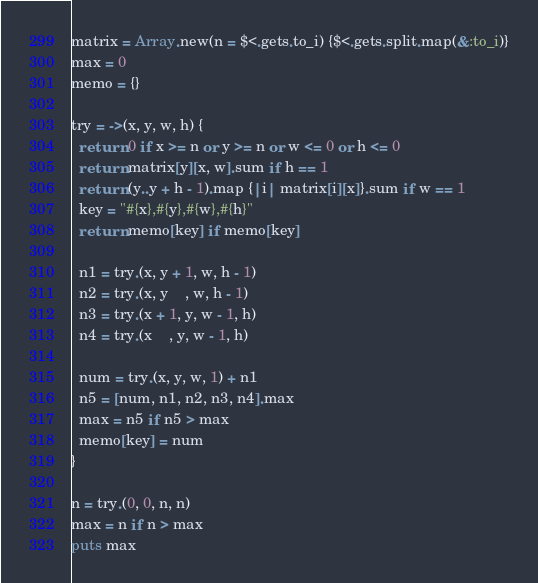Convert code to text. <code><loc_0><loc_0><loc_500><loc_500><_Ruby_>matrix = Array.new(n = $<.gets.to_i) {$<.gets.split.map(&:to_i)}
max = 0
memo = {}

try = ->(x, y, w, h) {
  return 0 if x >= n or y >= n or w <= 0 or h <= 0
  return matrix[y][x, w].sum if h == 1
  return (y..y + h - 1).map {|i| matrix[i][x]}.sum if w == 1
  key = "#{x},#{y},#{w},#{h}"
  return memo[key] if memo[key]
  
  n1 = try.(x, y + 1, w, h - 1)
  n2 = try.(x, y    , w, h - 1)
  n3 = try.(x + 1, y, w - 1, h)
  n4 = try.(x    , y, w - 1, h)
  
  num = try.(x, y, w, 1) + n1
  n5 = [num, n1, n2, n3, n4].max
  max = n5 if n5 > max
  memo[key] = num
}

n = try.(0, 0, n, n)
max = n if n > max
puts max
</code> 